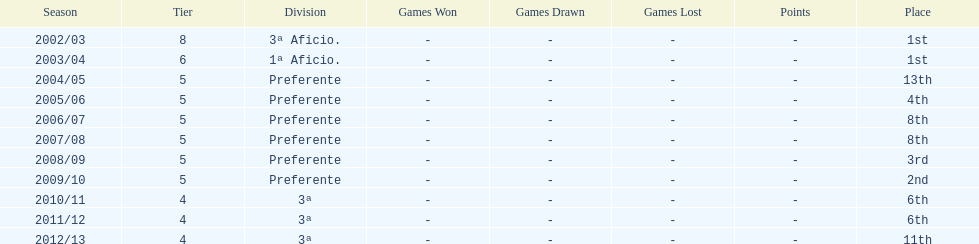How many years was the team in the 3 a division? 4. 